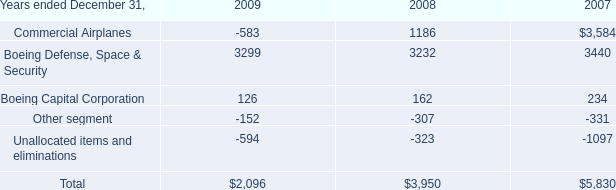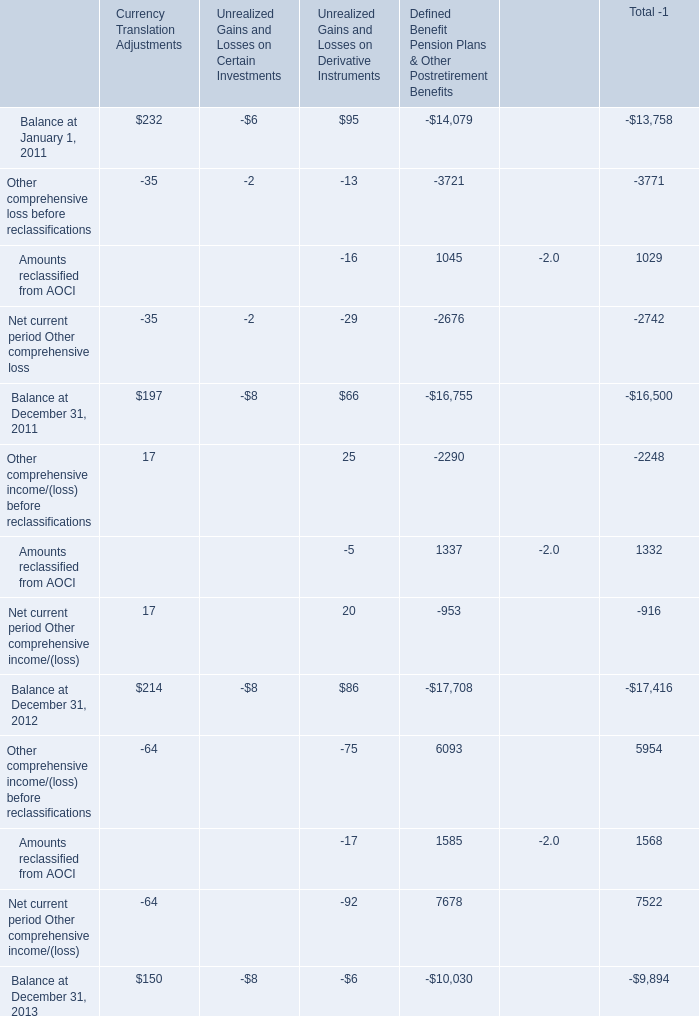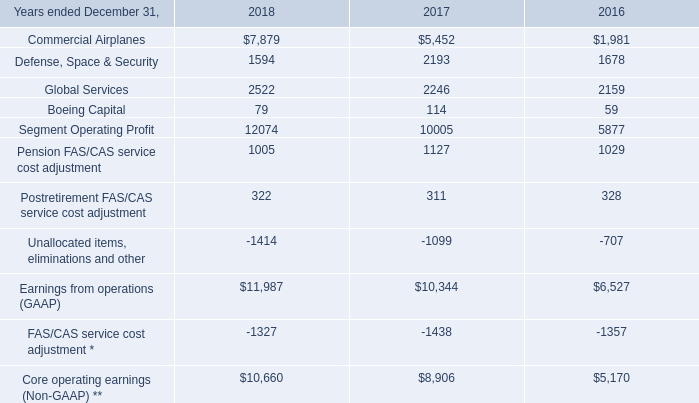What is the ratio of Boeing Defense, Space & Security in 2009 to the Commercial Airplanes in 2018 ? 
Computations: (3299 / 7879)
Answer: 0.41871. 